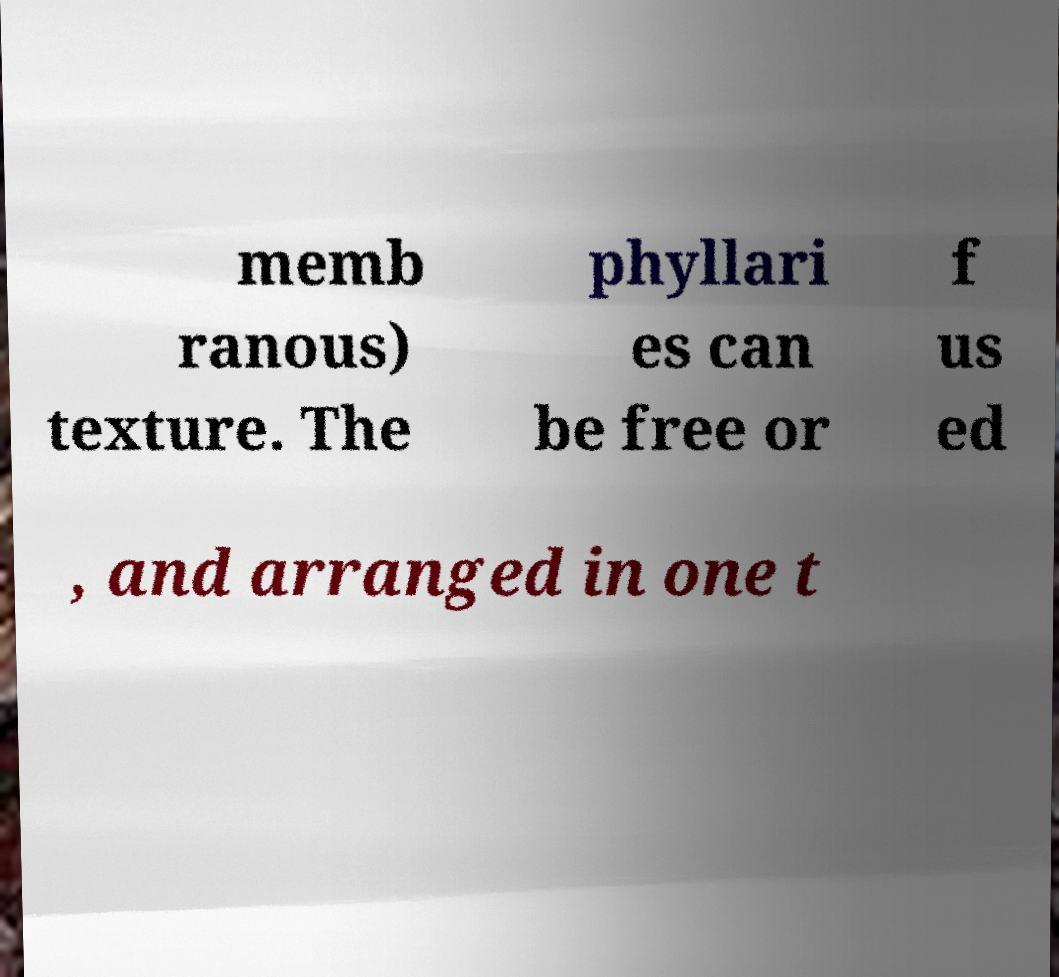Please read and relay the text visible in this image. What does it say? memb ranous) texture. The phyllari es can be free or f us ed , and arranged in one t 